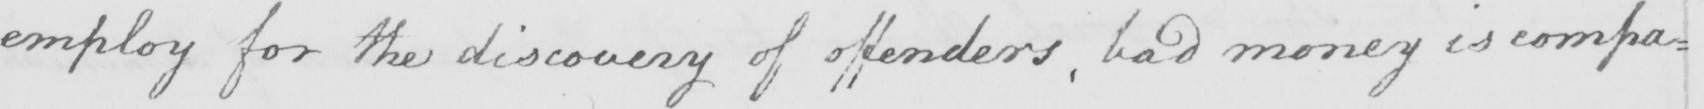Can you tell me what this handwritten text says? employ for the discovery of offenders , bad money is compa= 